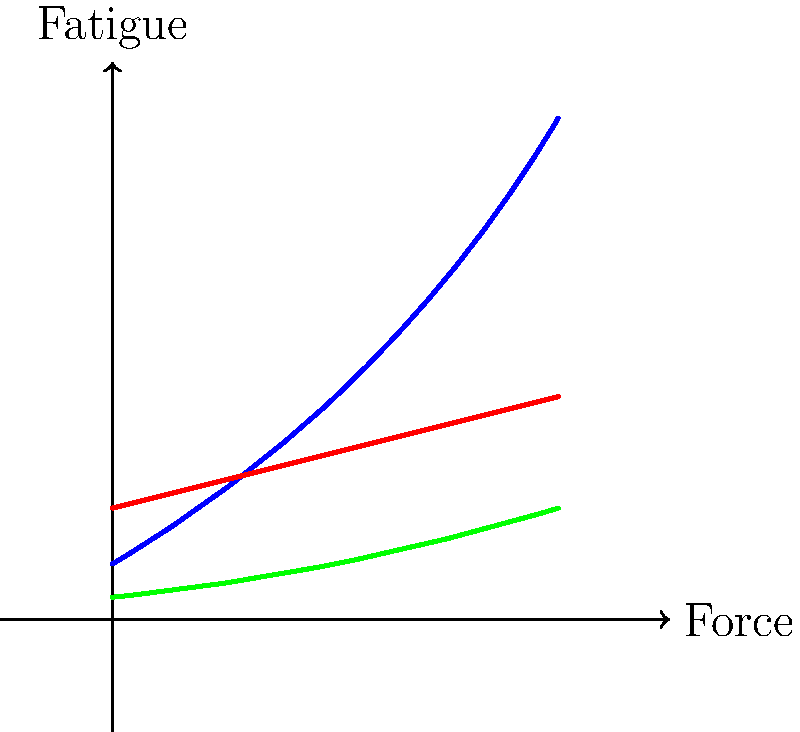As a frequent attendee of live music events in Scranton, you've noticed singers using different microphone holding techniques. Based on the graph shown, which microphone technique would likely cause the least fatigue for a singer during a long performance? To answer this question, we need to analyze the graph and understand what it represents:

1. The x-axis represents the force applied, which can be interpreted as the duration or intensity of the performance.
2. The y-axis represents the fatigue experienced by the singer.
3. Three different microphone techniques are shown: classic grip (blue), ice cream grip (red), and mic stand (green).

Let's examine each technique:

1. Classic grip (blue line): This shows a rapidly increasing fatigue level as the performance progresses.
2. Ice cream grip (red line): This demonstrates a moderate increase in fatigue over time.
3. Mic stand (green line): This exhibits the slowest increase in fatigue throughout the performance.

The technique that causes the least fatigue will be the one with the lowest y-value (fatigue level) at any given x-value (force/duration).

Comparing the three lines, we can clearly see that the green line (representing the mic stand) remains the lowest throughout the graph. This indicates that using a mic stand would result in the least fatigue for the singer during a long performance.

The mic stand technique likely causes less fatigue because:
1. It doesn't require the singer to hold the microphone, reducing arm and shoulder strain.
2. It allows for more freedom of movement and gestures during the performance.
3. The singer can focus more on their vocal technique without the added task of managing the microphone position.
Answer: Mic stand 